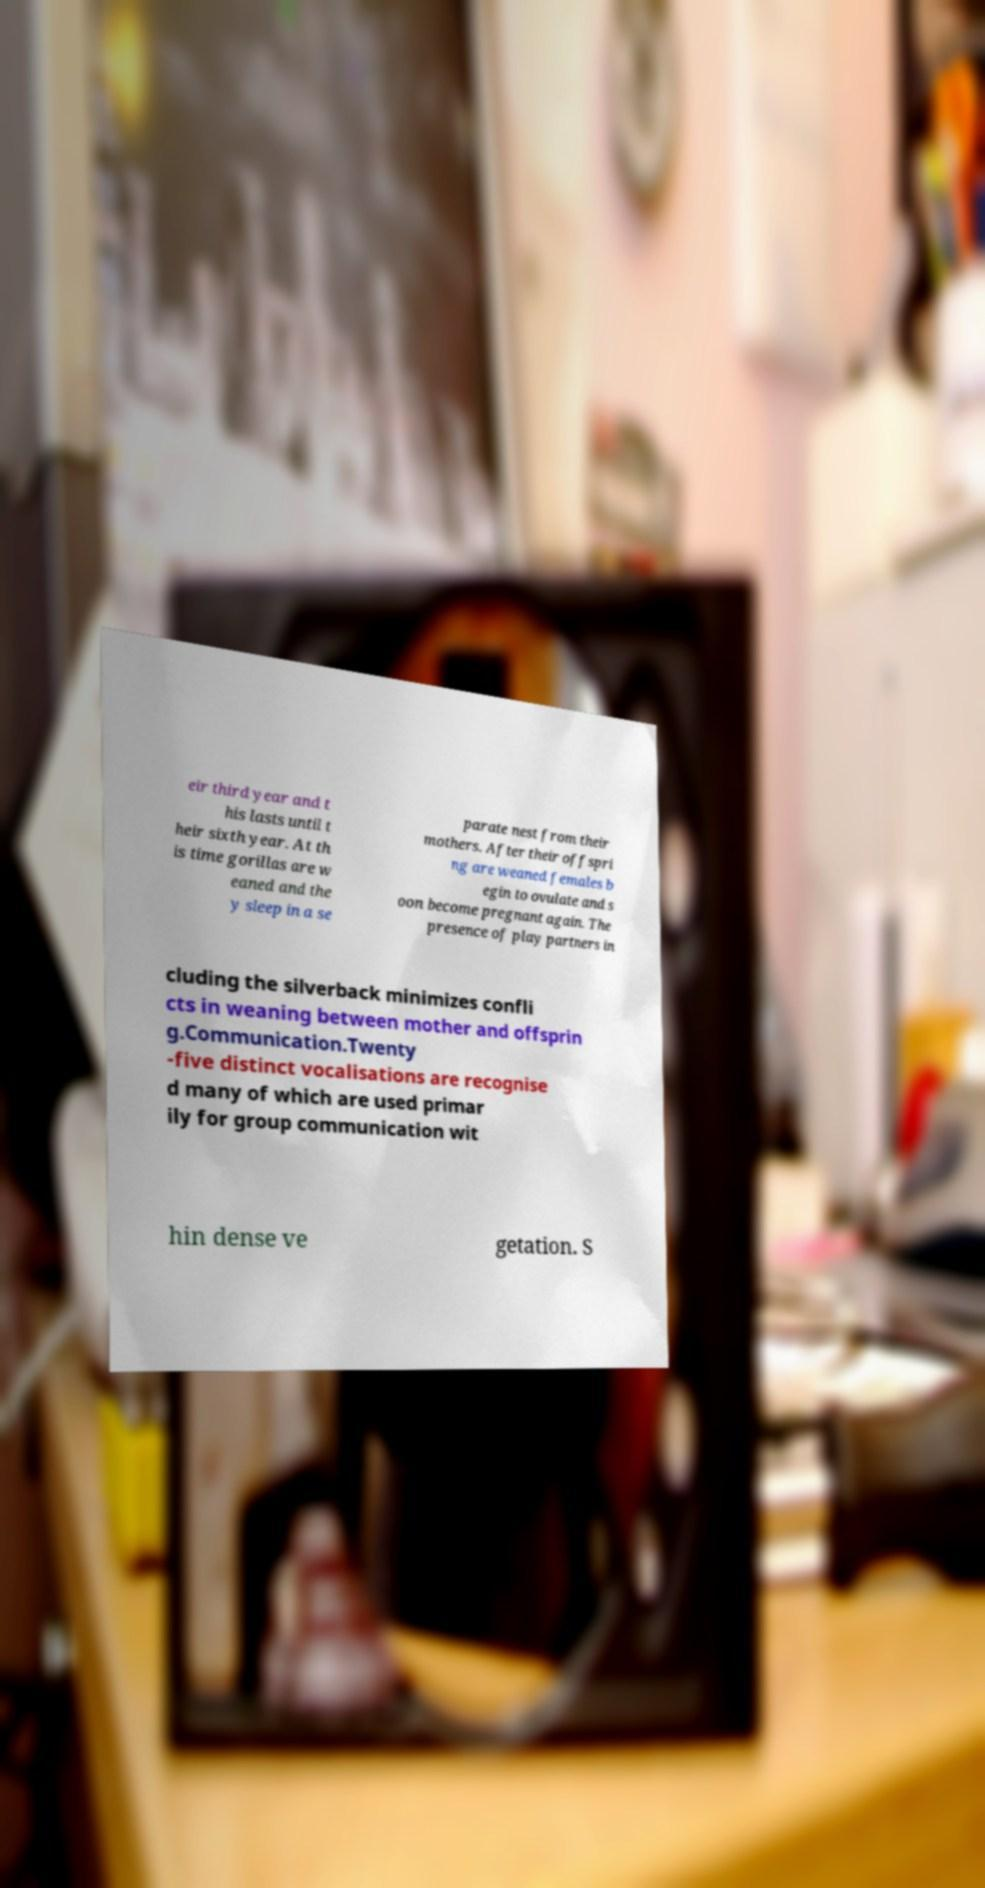What messages or text are displayed in this image? I need them in a readable, typed format. eir third year and t his lasts until t heir sixth year. At th is time gorillas are w eaned and the y sleep in a se parate nest from their mothers. After their offspri ng are weaned females b egin to ovulate and s oon become pregnant again. The presence of play partners in cluding the silverback minimizes confli cts in weaning between mother and offsprin g.Communication.Twenty -five distinct vocalisations are recognise d many of which are used primar ily for group communication wit hin dense ve getation. S 